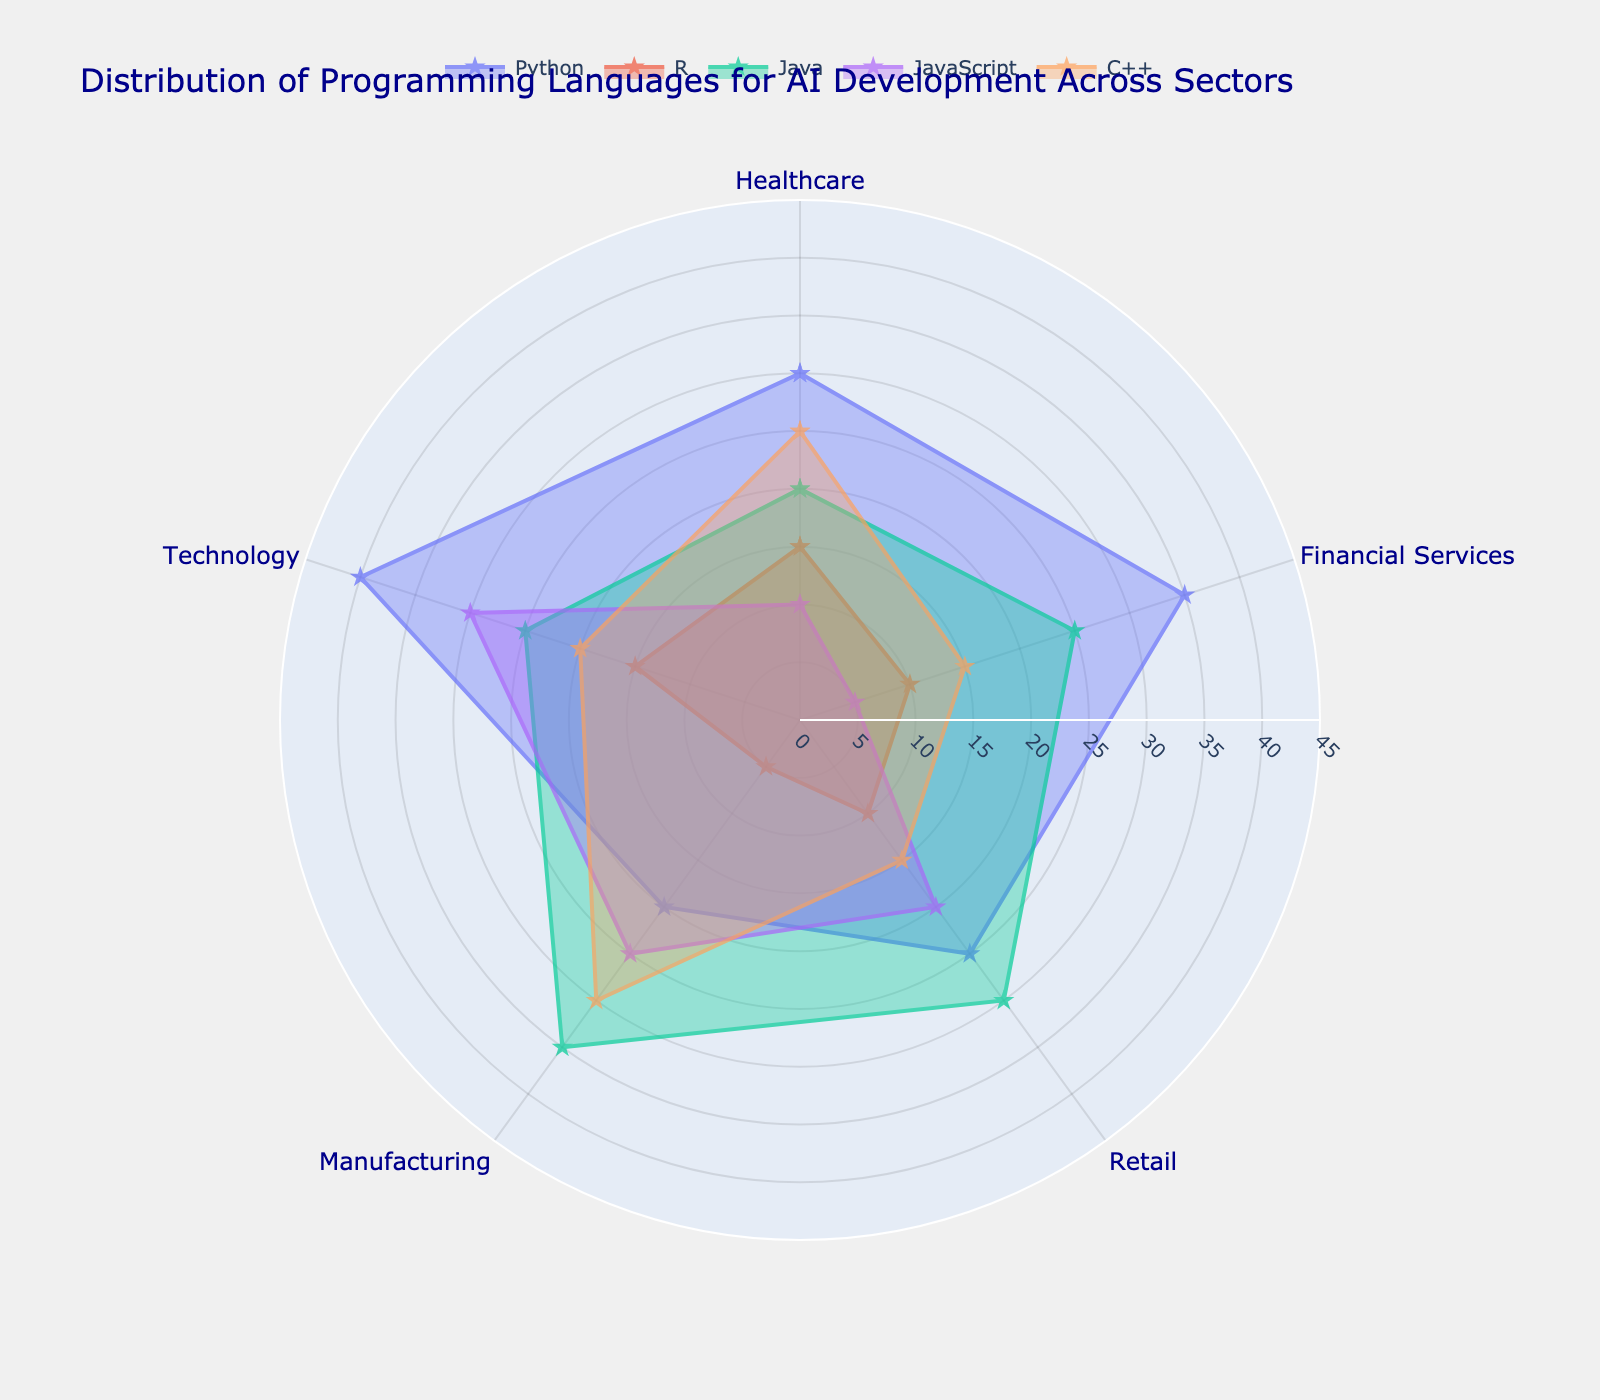What's the title of the chart? The title can be found at the top of the figure. It states the purpose of the chart, which is to display distribution across sectors.
Answer: Distribution of Programming Languages for AI Development Across Sectors How many sectors are represented in the chart? Count the unique sectors listed along the circular axis or given in the data. There are five unique sectors.
Answer: 5 Which programming language has the highest percentage in the Technology sector? Check the "Technology" section and compare the percentages for each language. Python has the highest percentage.
Answer: Python What is the total percentage of usage for Python across all sectors? Sum the percentages for Python across all sectors: 30 (Healthcare) + 35 (Financial Services) + 25 (Retail) + 20 (Manufacturing) + 40 (Technology) = 150.
Answer: 150 Which sector shows the highest use of JavaScript? Observe the sections associated with JavaScript and compare the percentages. The Technology sector has the highest percentage.
Answer: Technology What is the difference in percentage usage between Java in Manufacturing and Python in Retail? Subtract the percentage of Python in Retail from the percentage of Java in Manufacturing: 35 (Java) - 25 (Python) = 10.
Answer: 10 If you average the percentage usage of C++ across all sectors, what is the result? Add up the C++ percentages and divide by the number of sectors: (25+15+15+30+20) / 5 = 105 / 5 = 21.
Answer: 21 Which programming language shows a balanced distribution across all sectors, meaning relatively close percentages? Compare the values across sectors for each language. Python has varying percentages, while R has relatively similar values: 15, 10, 10, 5, 15.
Answer: R Among Healthcare and Retail, which sector has a higher percentage usage of R? Compare the percentages for R in the Healthcare and Retail sectors: 15 (Healthcare) vs. 10 (Retail). Healthcare is higher.
Answer: Healthcare In which sector does C++ show its maximum usage? Look at the values for C++ across all sectors and find the highest value. The Manufacturing sector has the highest percentage.
Answer: Manufacturing 